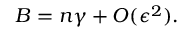Convert formula to latex. <formula><loc_0><loc_0><loc_500><loc_500>B = n \gamma + O ( \epsilon ^ { 2 } ) .</formula> 